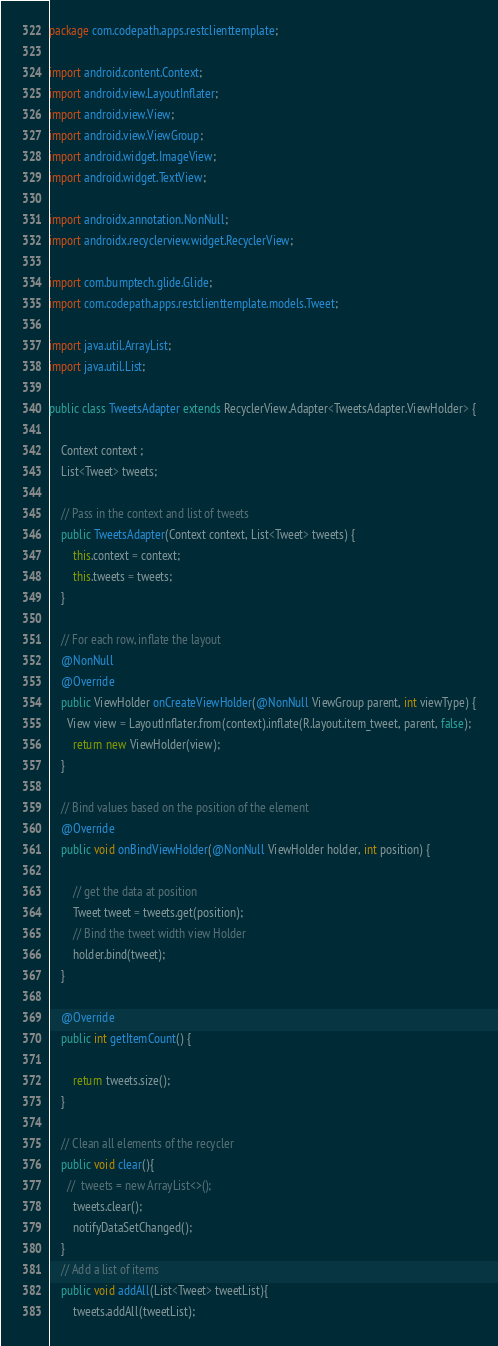<code> <loc_0><loc_0><loc_500><loc_500><_Java_>package com.codepath.apps.restclienttemplate;

import android.content.Context;
import android.view.LayoutInflater;
import android.view.View;
import android.view.ViewGroup;
import android.widget.ImageView;
import android.widget.TextView;

import androidx.annotation.NonNull;
import androidx.recyclerview.widget.RecyclerView;

import com.bumptech.glide.Glide;
import com.codepath.apps.restclienttemplate.models.Tweet;

import java.util.ArrayList;
import java.util.List;

public class TweetsAdapter extends RecyclerView.Adapter<TweetsAdapter.ViewHolder> {

    Context context ;
    List<Tweet> tweets;

    // Pass in the context and list of tweets
    public TweetsAdapter(Context context, List<Tweet> tweets) {
        this.context = context;
        this.tweets = tweets;
    }

    // For each row, inflate the layout
    @NonNull
    @Override
    public ViewHolder onCreateViewHolder(@NonNull ViewGroup parent, int viewType) {
      View view = LayoutInflater.from(context).inflate(R.layout.item_tweet, parent, false);
        return new ViewHolder(view);
    }

    // Bind values based on the position of the element
    @Override
    public void onBindViewHolder(@NonNull ViewHolder holder, int position) {

        // get the data at position
        Tweet tweet = tweets.get(position);
        // Bind the tweet width view Holder
        holder.bind(tweet);
    }

    @Override
    public int getItemCount() {

        return tweets.size();
    }

    // Clean all elements of the recycler
    public void clear(){
      //  tweets = new ArrayList<>();
        tweets.clear();
        notifyDataSetChanged();
    }
    // Add a list of items
    public void addAll(List<Tweet> tweetList){
        tweets.addAll(tweetList);</code> 